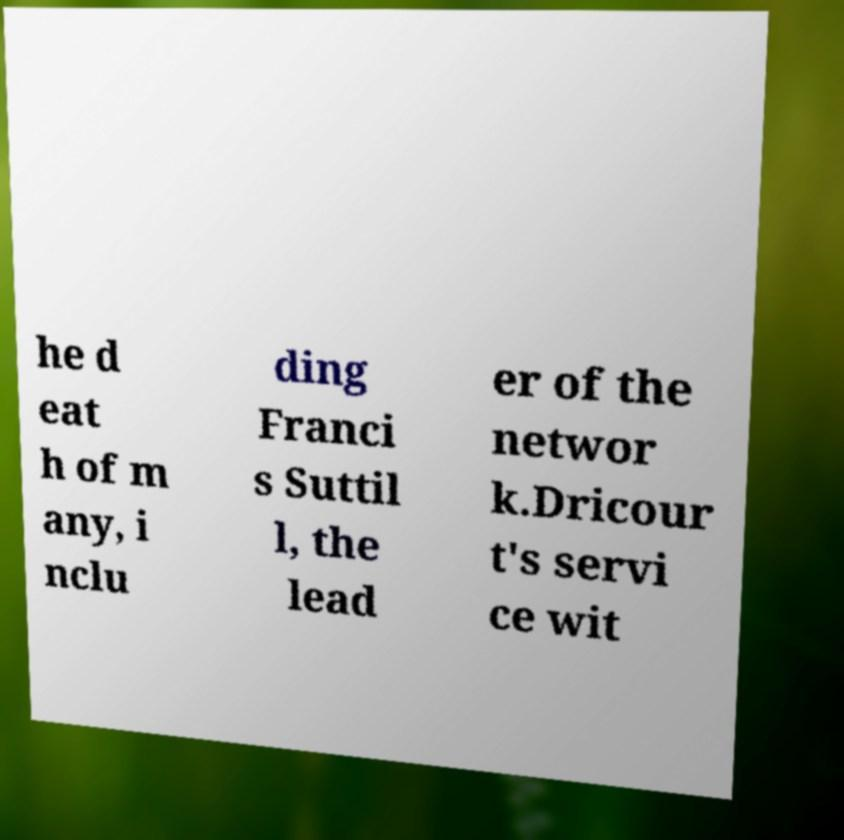Can you read and provide the text displayed in the image?This photo seems to have some interesting text. Can you extract and type it out for me? he d eat h of m any, i nclu ding Franci s Suttil l, the lead er of the networ k.Dricour t's servi ce wit 